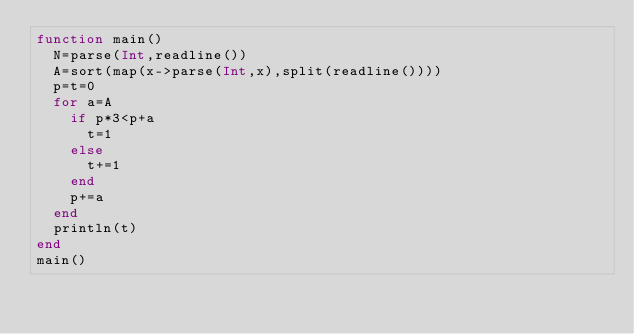Convert code to text. <code><loc_0><loc_0><loc_500><loc_500><_Julia_>function main()
  N=parse(Int,readline())
  A=sort(map(x->parse(Int,x),split(readline())))
  p=t=0
  for a=A
    if p*3<p+a
      t=1
    else
      t+=1
    end
    p+=a
  end
  println(t)
end
main()</code> 